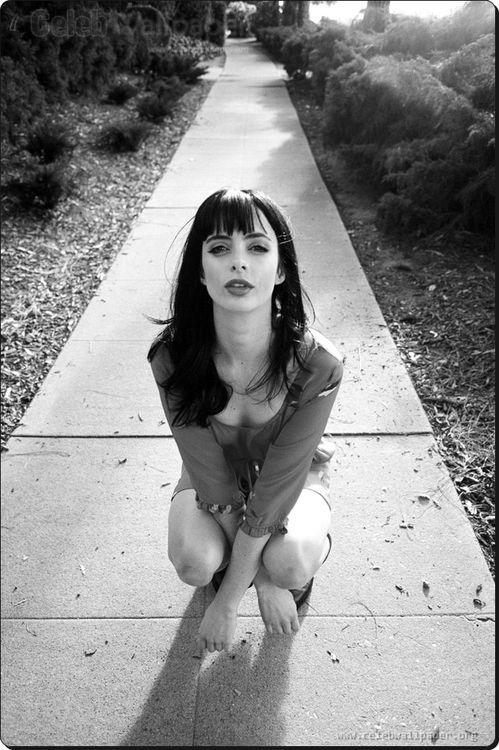Can you describe any artistic elements used in this photo? The photo employs a monochromatic color scheme which enhances the dramatic impact and focuses attention on textures and contrasts, such as the smoothness of her blouse versus the rough sidewalk. The vertical and horizontal lines formed by the sidewalk direct the viewer's eyes towards the subject, while the natural light appears to spotlight her, creating an almost theatrical ambiance. 